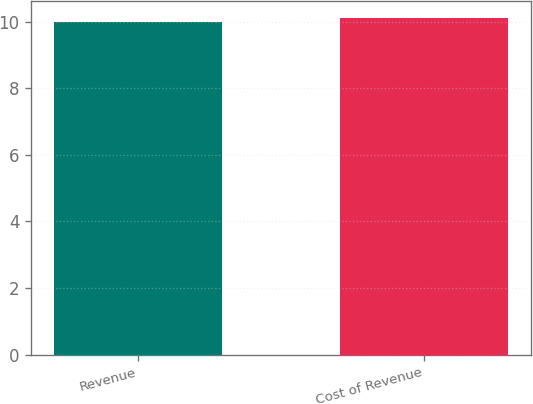Convert chart. <chart><loc_0><loc_0><loc_500><loc_500><bar_chart><fcel>Revenue<fcel>Cost of Revenue<nl><fcel>10<fcel>10.1<nl></chart> 